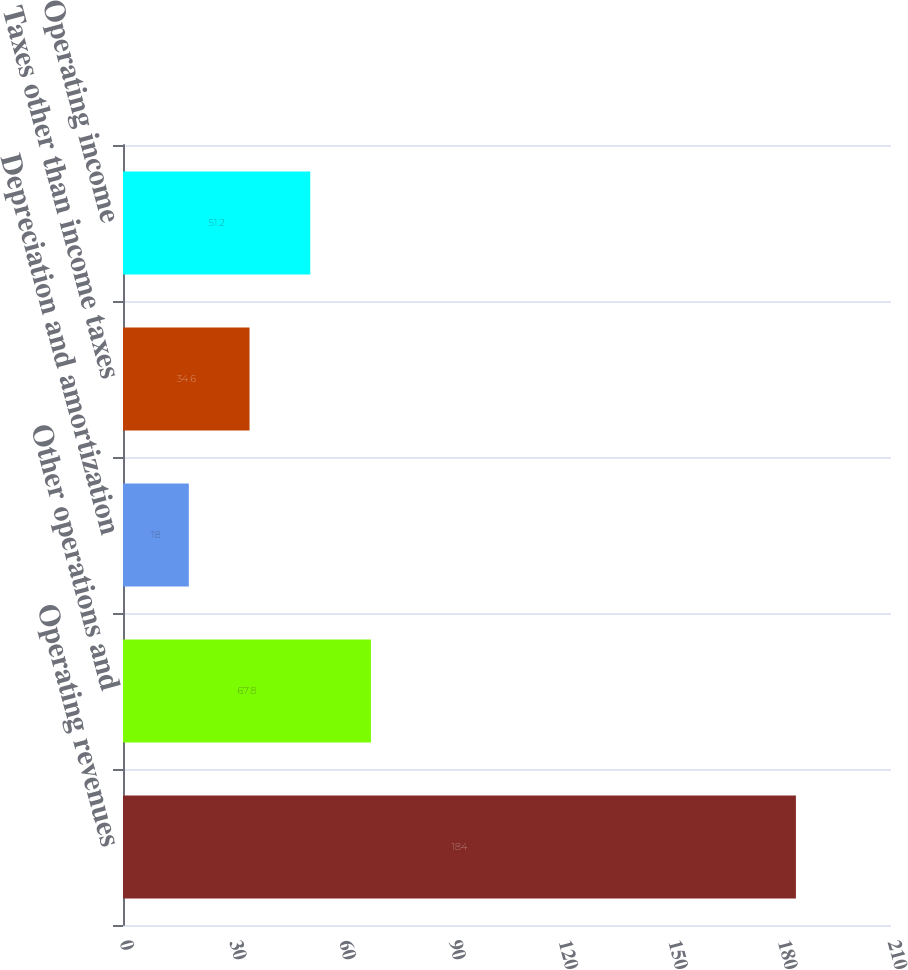Convert chart. <chart><loc_0><loc_0><loc_500><loc_500><bar_chart><fcel>Operating revenues<fcel>Other operations and<fcel>Depreciation and amortization<fcel>Taxes other than income taxes<fcel>Operating income<nl><fcel>184<fcel>67.8<fcel>18<fcel>34.6<fcel>51.2<nl></chart> 